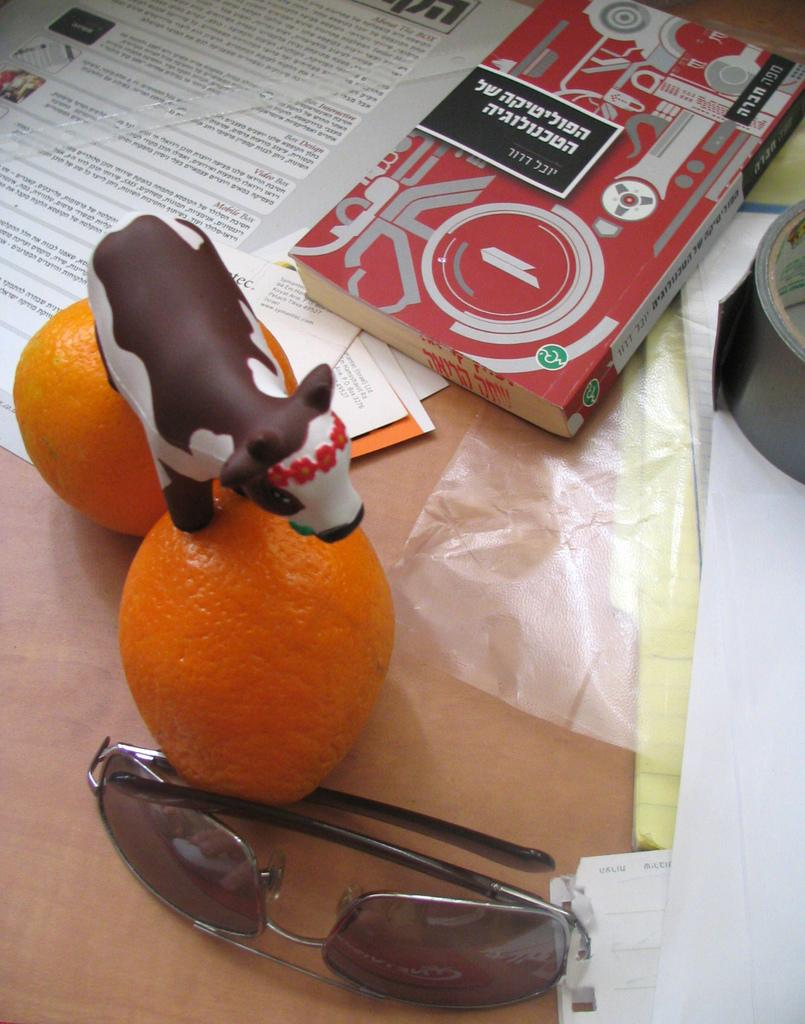What type of objects can be seen in the image? There are books, papers, goggles, two oranges, and a toy cow in the image. What might be used for reading or writing in the image? The books and papers in the image might be used for reading or writing. What type of eyewear is present in the image? There are goggles in the image. How many oranges are visible in the image? There are two oranges in the image. What type of toy is present in the image? There is a toy cow in the image. Where might these objects be located in the image? The objects are likely on a table in the image. What type of setting might the image be taken in? The image is likely taken in a room. What type of creature is working alongside the laborer in the image? There is no laborer or creature present in the image. What is the mind of the toy cow thinking in the image? Toys do not have minds or thoughts, so this question cannot be answered. 